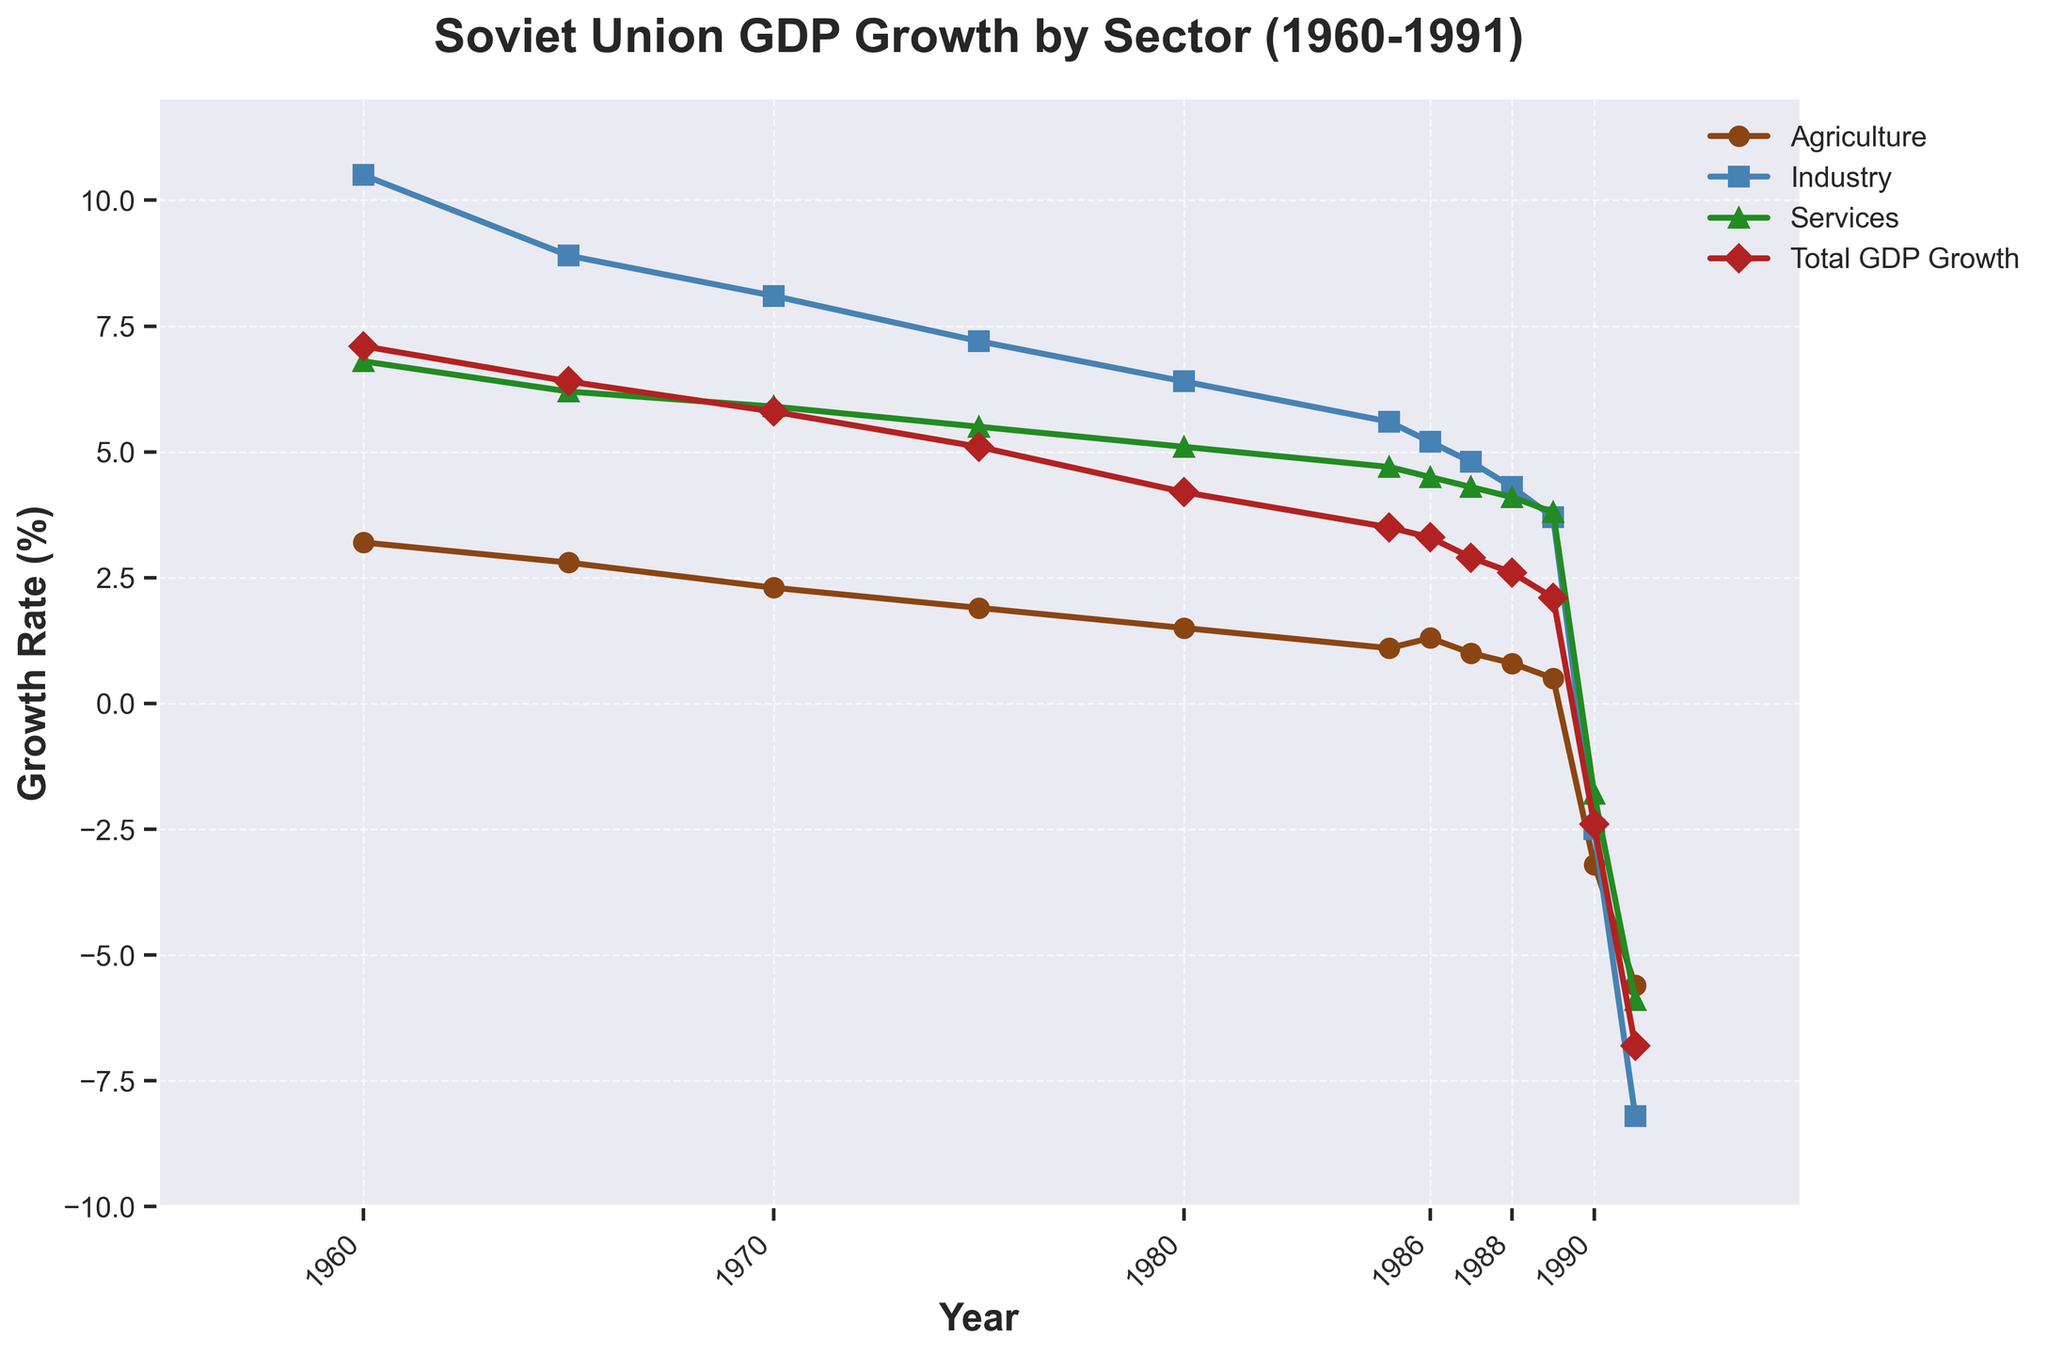What was the growth rate of the agriculture sector in 1990? The line for the agriculture sector shows a value of -3.2% for the year 1990.
Answer: -3.2% How did the total GDP growth change from 1985 to 1991? The total GDP growth decreased from 3.5% in 1985 to -6.8% in 1991. The change in growth rate can be calculated as 3.5% - (-6.8%) = 3.5% + 6.8% = 10.3%.
Answer: Decreased by 10.3% Which sector experienced the highest growth in 1980? In 1980, the industry sector had the highest growth rate, which is shown as 6.4% on the chart compared to agriculture (1.5%) and services (5.1%).
Answer: Industry sector In which year did all sectors experience negative growth rates? All sectors – agriculture, industry, and services – experienced negative growth rates in the year 1991, as depicted by their values on the plot.
Answer: 1991 How many years did the total GDP growth rate remain above 5%? The total GDP growth rate remained above 5% from 1960 to 1975, making it a total of 4 years shown: 1960, 1965, 1970, and 1975.
Answer: 4 years Which sector's growth rate declined the most sharply between 1989 and 1990? The agriculture sector's growth rate declined the most sharply from 0.5% in 1989 to -3.2% in 1990, which is a decline of 3.7 percentage points.
Answer: Agriculture sector What was the average growth rate of the services sector from 1960 to 1980? The growth rates of the services sector from 1960 to 1980 are 6.8%, 6.2%, 5.9%, 5.5%, and 5.1%. Adding these values gives a total of 29.5%. Dividing by 5 (the number of years) gives an average growth rate of 29.5% / 5 = 5.9%.
Answer: 5.9% In which year was the industry's growth rate closest to the total GDP growth rate? In 1986, the industry sector's growth rate was 5.2%, and the total GDP growth rate was 3.3%. These values are closer together compared to other years, making it the year when they were closest.
Answer: 1986 